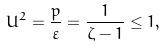Convert formula to latex. <formula><loc_0><loc_0><loc_500><loc_500>U ^ { 2 } = \frac { p } { \varepsilon } = \frac { 1 } { \zeta - 1 } \leq 1 ,</formula> 